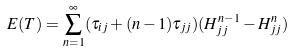<formula> <loc_0><loc_0><loc_500><loc_500>E ( T ) = \sum _ { n = 1 } ^ { \infty } ( \tau _ { i j } + ( n - 1 ) \tau _ { j j } ) ( H _ { j j } ^ { n - 1 } - H _ { j j } ^ { n } )</formula> 